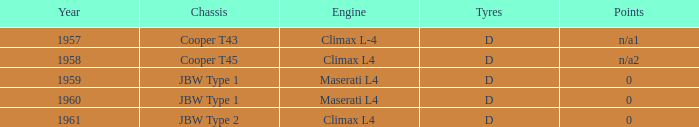In 1961, what type of engine was used? Climax L4. 